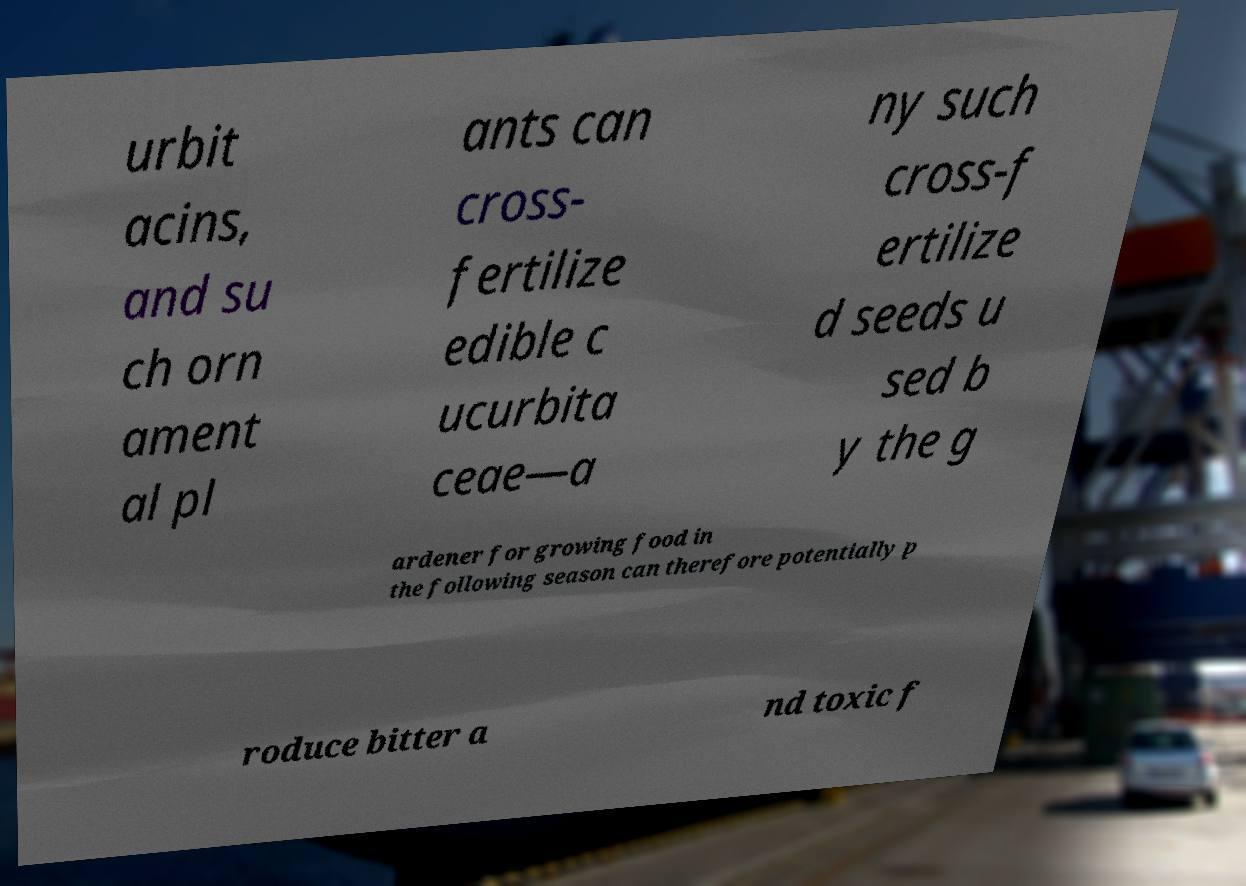Can you read and provide the text displayed in the image?This photo seems to have some interesting text. Can you extract and type it out for me? urbit acins, and su ch orn ament al pl ants can cross- fertilize edible c ucurbita ceae—a ny such cross-f ertilize d seeds u sed b y the g ardener for growing food in the following season can therefore potentially p roduce bitter a nd toxic f 